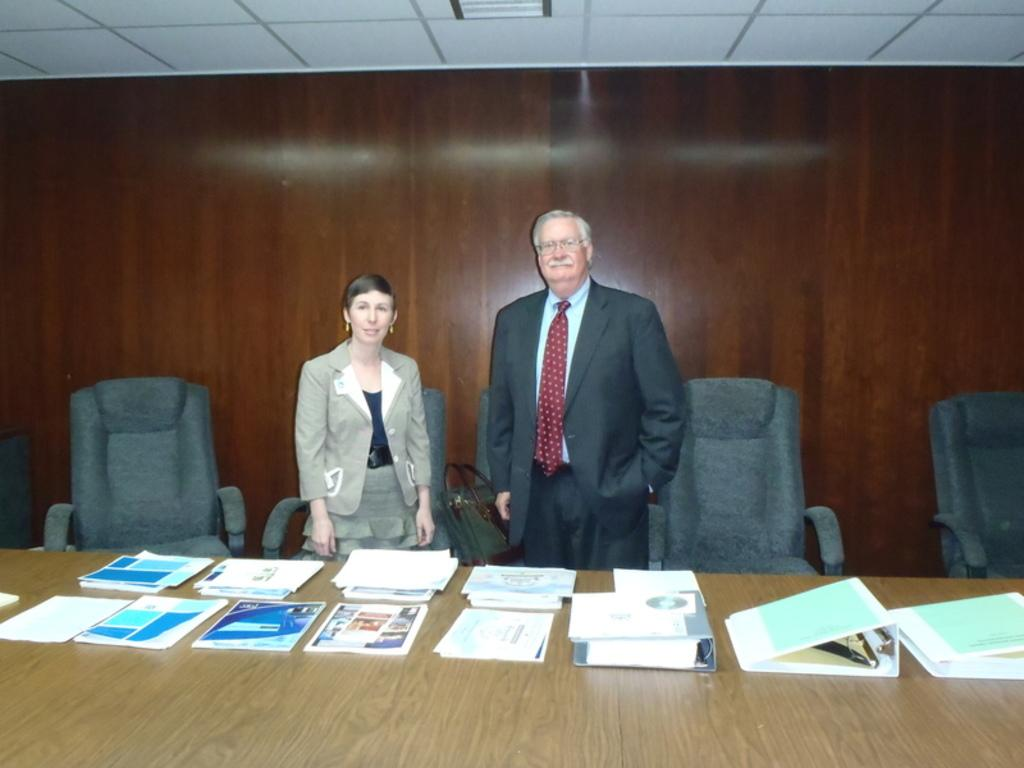What type of furniture is present in the room? There are chairs and tables in the room. What is on top of the tables in the room? Papers and files are on the tables in the room. Are there any people in the room? Yes, there is a woman and a man standing in the room. What type of train can be seen in the room? There is no train present in the room; it is an indoor setting with chairs, tables, papers, files, a woman, and a man. What songs are being sung by the people in the room? There is no mention of singing or songs in the room; the focus is on the presence of chairs, tables, papers, files, a woman, and a man. 